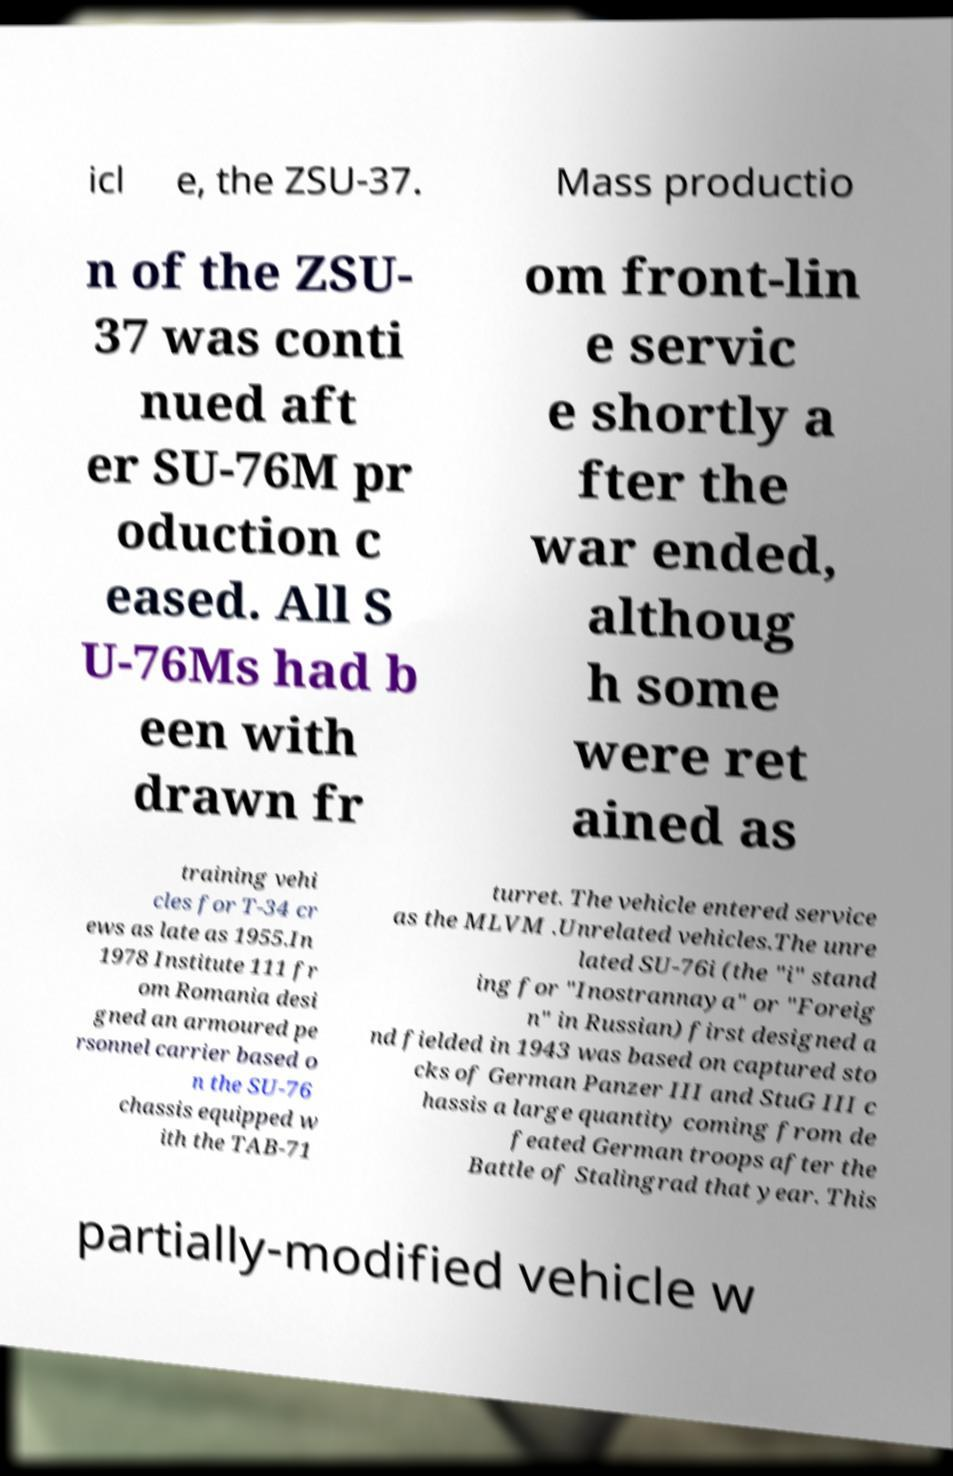I need the written content from this picture converted into text. Can you do that? icl e, the ZSU-37. Mass productio n of the ZSU- 37 was conti nued aft er SU-76M pr oduction c eased. All S U-76Ms had b een with drawn fr om front-lin e servic e shortly a fter the war ended, althoug h some were ret ained as training vehi cles for T-34 cr ews as late as 1955.In 1978 Institute 111 fr om Romania desi gned an armoured pe rsonnel carrier based o n the SU-76 chassis equipped w ith the TAB-71 turret. The vehicle entered service as the MLVM .Unrelated vehicles.The unre lated SU-76i (the "i" stand ing for "Inostrannaya" or "Foreig n" in Russian) first designed a nd fielded in 1943 was based on captured sto cks of German Panzer III and StuG III c hassis a large quantity coming from de feated German troops after the Battle of Stalingrad that year. This partially-modified vehicle w 